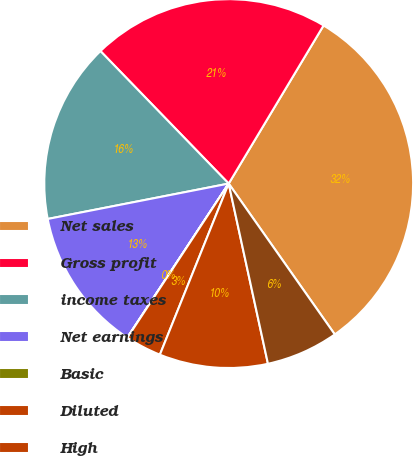Convert chart. <chart><loc_0><loc_0><loc_500><loc_500><pie_chart><fcel>Net sales<fcel>Gross profit<fcel>income taxes<fcel>Net earnings<fcel>Basic<fcel>Diluted<fcel>High<fcel>Low<nl><fcel>31.64%<fcel>20.84%<fcel>15.83%<fcel>12.66%<fcel>0.01%<fcel>3.17%<fcel>9.5%<fcel>6.34%<nl></chart> 